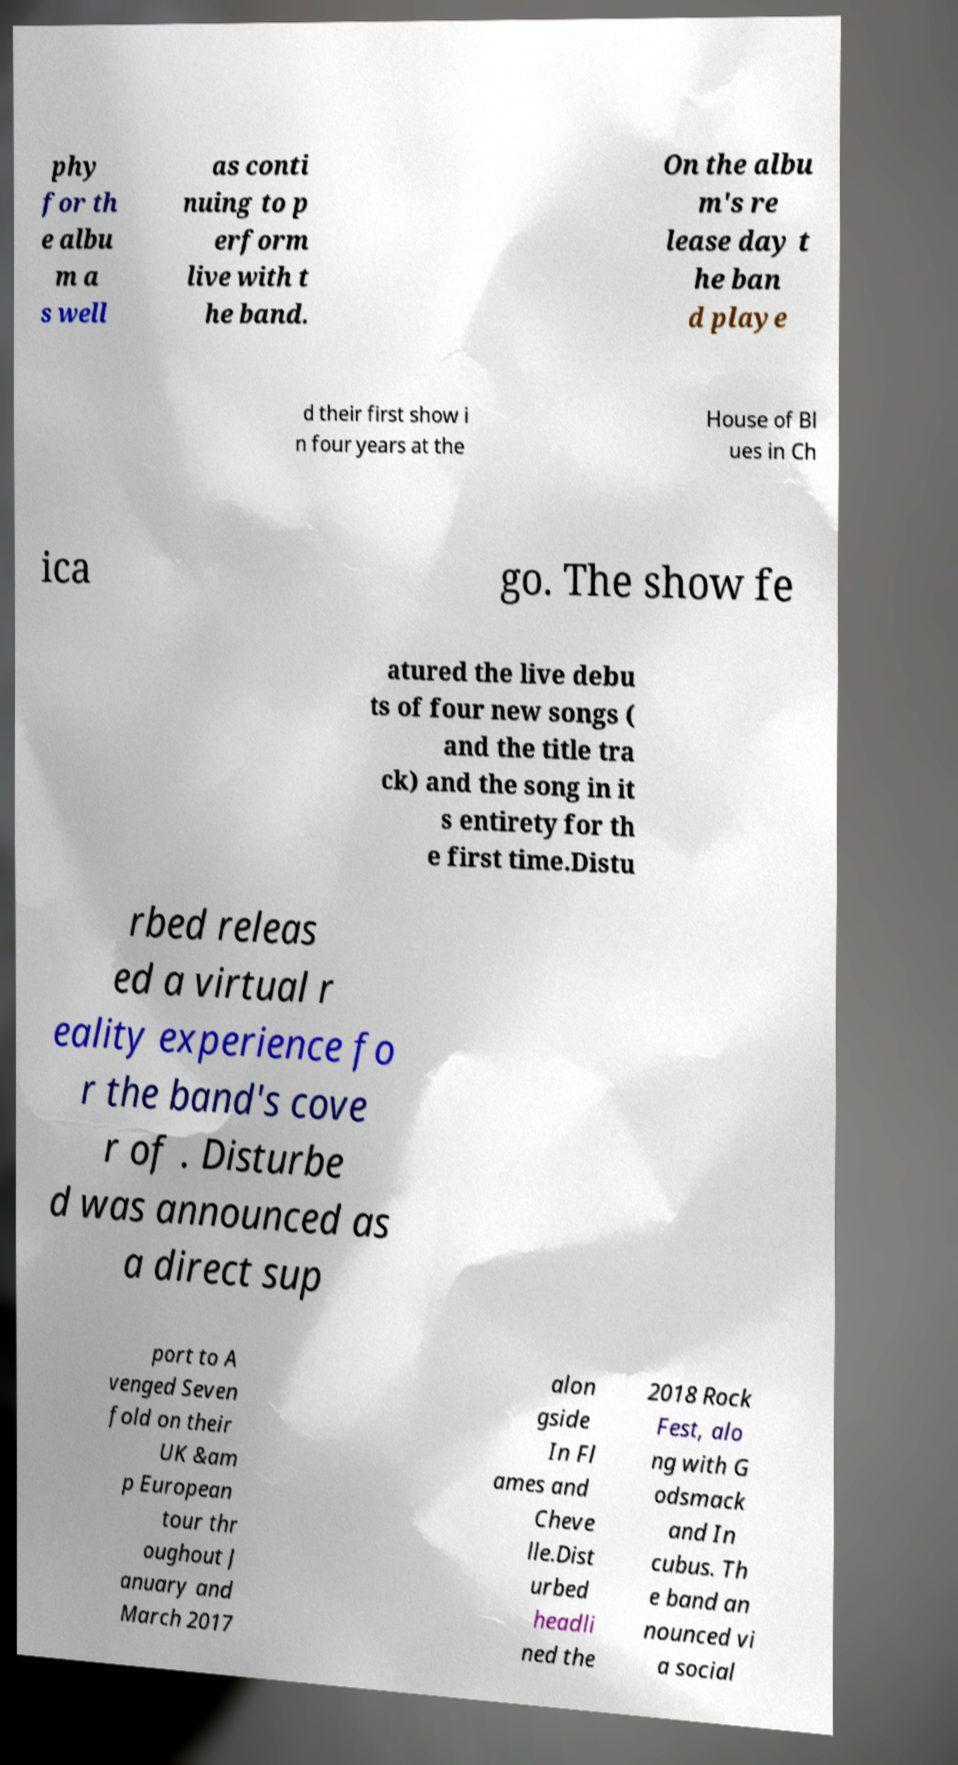What messages or text are displayed in this image? I need them in a readable, typed format. phy for th e albu m a s well as conti nuing to p erform live with t he band. On the albu m's re lease day t he ban d playe d their first show i n four years at the House of Bl ues in Ch ica go. The show fe atured the live debu ts of four new songs ( and the title tra ck) and the song in it s entirety for th e first time.Distu rbed releas ed a virtual r eality experience fo r the band's cove r of . Disturbe d was announced as a direct sup port to A venged Seven fold on their UK &am p European tour thr oughout J anuary and March 2017 alon gside In Fl ames and Cheve lle.Dist urbed headli ned the 2018 Rock Fest, alo ng with G odsmack and In cubus. Th e band an nounced vi a social 